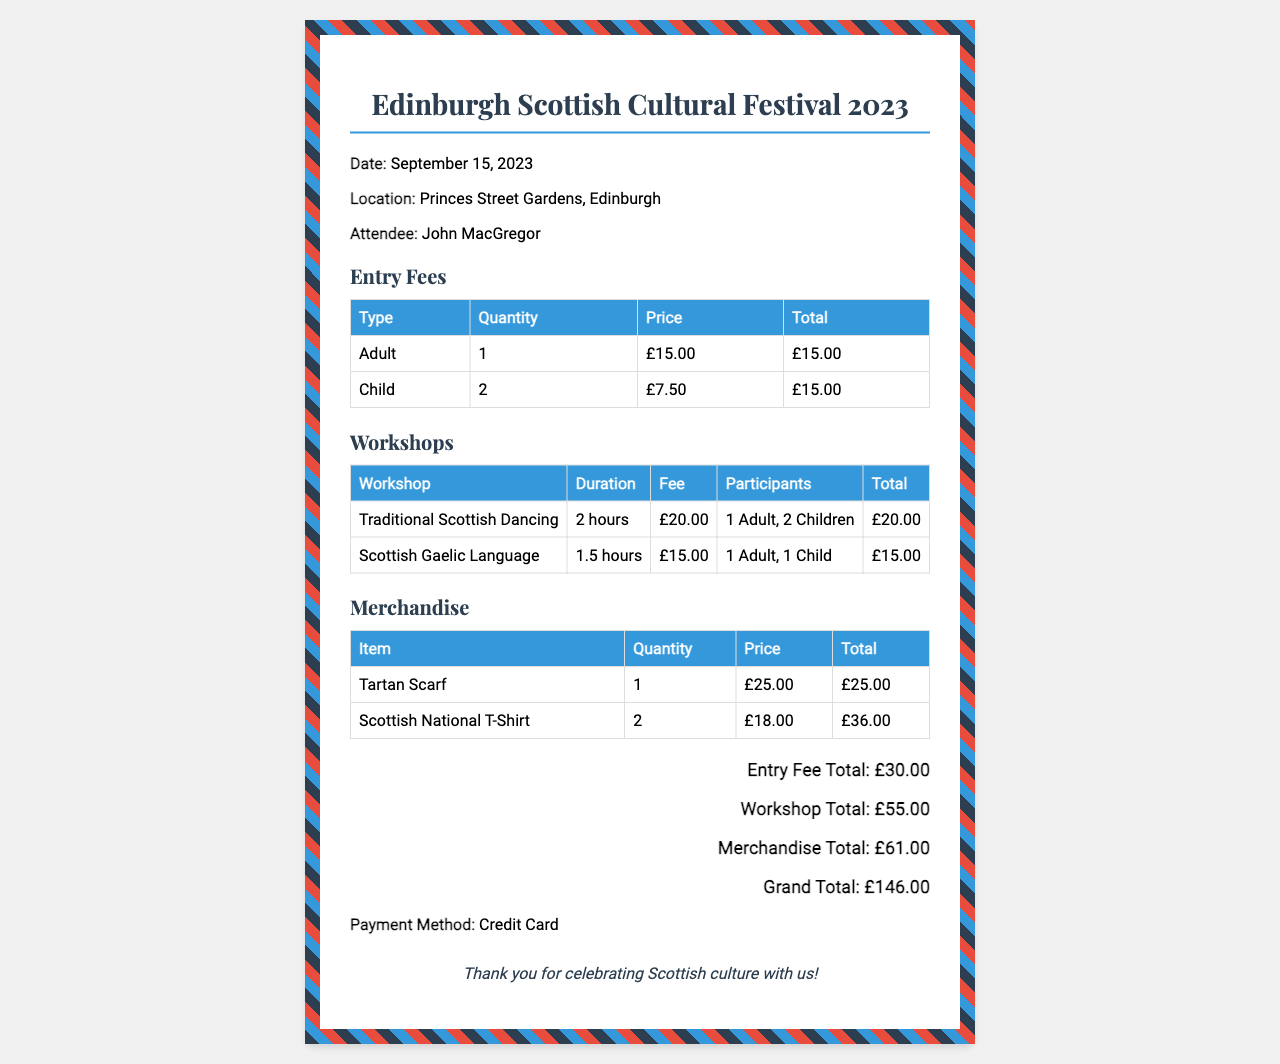What is the date of the festival? The date of the festival is explicitly mentioned in the document.
Answer: September 15, 2023 Who is the attendee listed on the receipt? The attendee's name is provided in the recipient information section of the document.
Answer: John MacGregor What is the total for entry fees? The entry fee total is calculated from the entries provided in the table for adult and child fees.
Answer: £30.00 How many participants were in the "Traditional Scottish Dancing" workshop? The document mentions the number of participants for each workshop, specifically for this one.
Answer: 3 What is the cost of one Tartan Scarf? The merchandise table lists the price for the Tartan Scarf.
Answer: £25.00 What is the grand total amount for the purchase? The grand total is the sum of all the individual totals listed at the bottom of the receipt.
Answer: £146.00 What was the method of payment? The document specifies the payment method used for the transaction.
Answer: Credit Card How many children attended the festival? The information can be inferred from the entry fees section of the receipt.
Answer: 2 What is the duration of the "Scottish Gaelic Language" workshop? The duration is stated in the workshop table under the "Duration" column.
Answer: 1.5 hours 